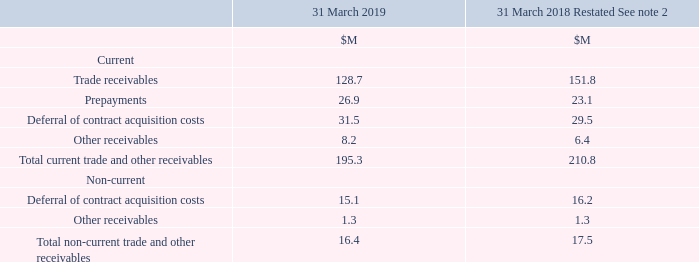20 Trade and Other Receivables
Trade receivables are non interest-bearing and are generally on 30–90 day payment terms depending on the geographical territory in which sales are generated. The carrying value of trade and other receivables also represents their fair value. During the year-ended 31 March 2019 a provision for impairment of $0.6M (2018: $0.6M) was recognised in operating expenses against receivables.
The net contract acquisition expense deferred within the Consolidated Statement of Profit or Loss was $0.9M of the total $259.9M of Sales and Marketing costs (2018: $8.4M / $239.9M).
What represents the fair value of trade and other receivables? The carrying value of trade and other receivables. What was recognised in operating expenses against receivables in 2019? A provision for impairment of $0.6m (2018: $0.6m). What are the components comprising the total non-current trade and other receivables? Deferral of contract acquisition costs, other receivables. In which year was the amount of Prepayments larger? 26.9>23.1
Answer: 2019. What was the change in trade receivables in 2019 from 2018?
Answer scale should be: million. 128.7-151.8
Answer: -23.1. What was the percentage change in trade receivables in 2019 from 2018?
Answer scale should be: percent. (128.7-151.8)/151.8
Answer: -15.22. 